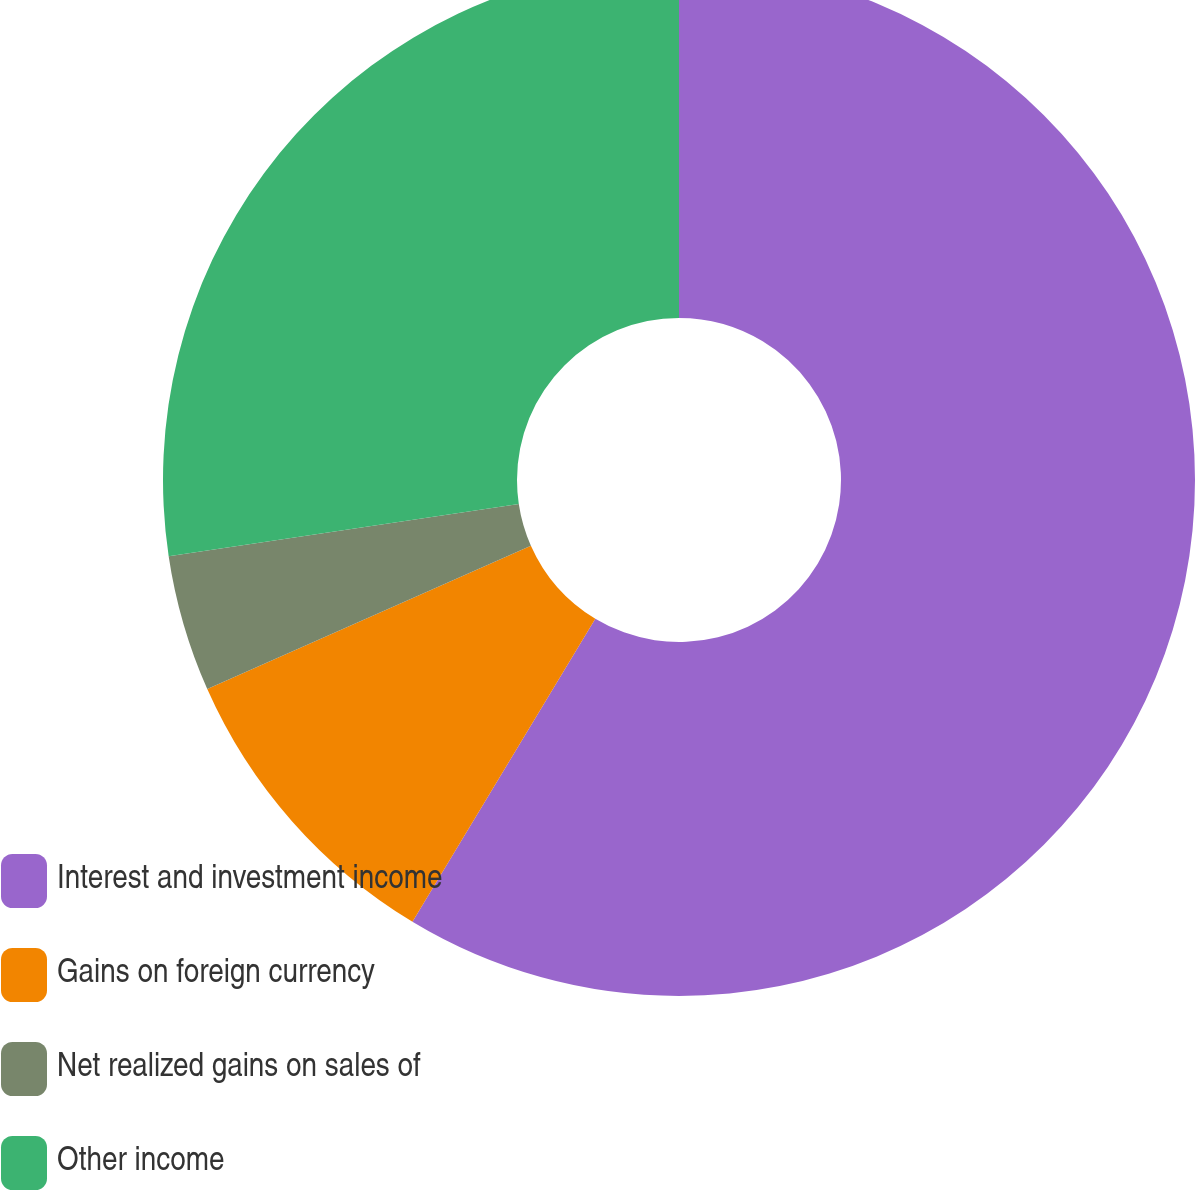Convert chart to OTSL. <chart><loc_0><loc_0><loc_500><loc_500><pie_chart><fcel>Interest and investment income<fcel>Gains on foreign currency<fcel>Net realized gains on sales of<fcel>Other income<nl><fcel>58.64%<fcel>9.72%<fcel>4.28%<fcel>27.36%<nl></chart> 